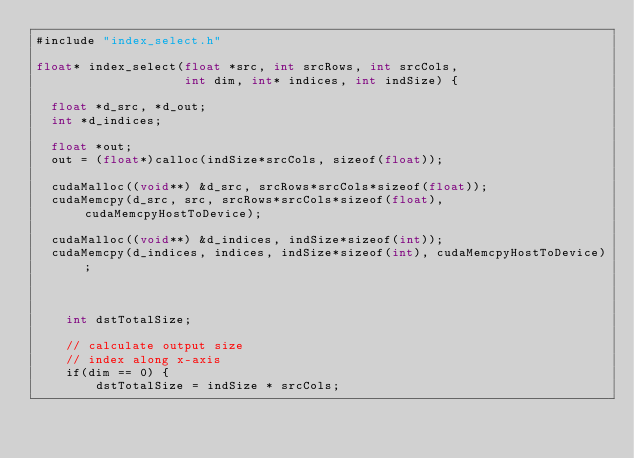<code> <loc_0><loc_0><loc_500><loc_500><_Cuda_>#include "index_select.h"

float* index_select(float *src, int srcRows, int srcCols,
                    int dim, int* indices, int indSize) {

	float *d_src, *d_out;
	int *d_indices;

	float *out;
	out = (float*)calloc(indSize*srcCols, sizeof(float));

	cudaMalloc((void**) &d_src, srcRows*srcCols*sizeof(float));
	cudaMemcpy(d_src, src, srcRows*srcCols*sizeof(float), cudaMemcpyHostToDevice);

	cudaMalloc((void**) &d_indices, indSize*sizeof(int));
	cudaMemcpy(d_indices, indices, indSize*sizeof(int), cudaMemcpyHostToDevice);
	


    int dstTotalSize;
    
    // calculate output size
    // index along x-axis
    if(dim == 0) {
        dstTotalSize = indSize * srcCols;</code> 